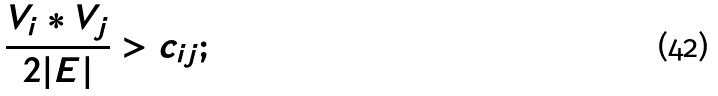Convert formula to latex. <formula><loc_0><loc_0><loc_500><loc_500>\frac { V _ { i } * V _ { j } } { 2 | E | } > c _ { i j } ;</formula> 